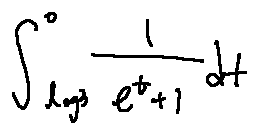<formula> <loc_0><loc_0><loc_500><loc_500>\int \lim i t s _ { \log 3 } ^ { 0 } \frac { 1 } { e ^ { t } + 1 } d t</formula> 